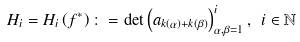<formula> <loc_0><loc_0><loc_500><loc_500>H _ { i } = H _ { i } \left ( f ^ { \ast } \right ) \colon = \det \left ( a _ { k \left ( \alpha \right ) + k ( \beta ) } \right ) _ { \alpha , \beta = 1 } ^ { i } , \ i \in \mathbb { N }</formula> 